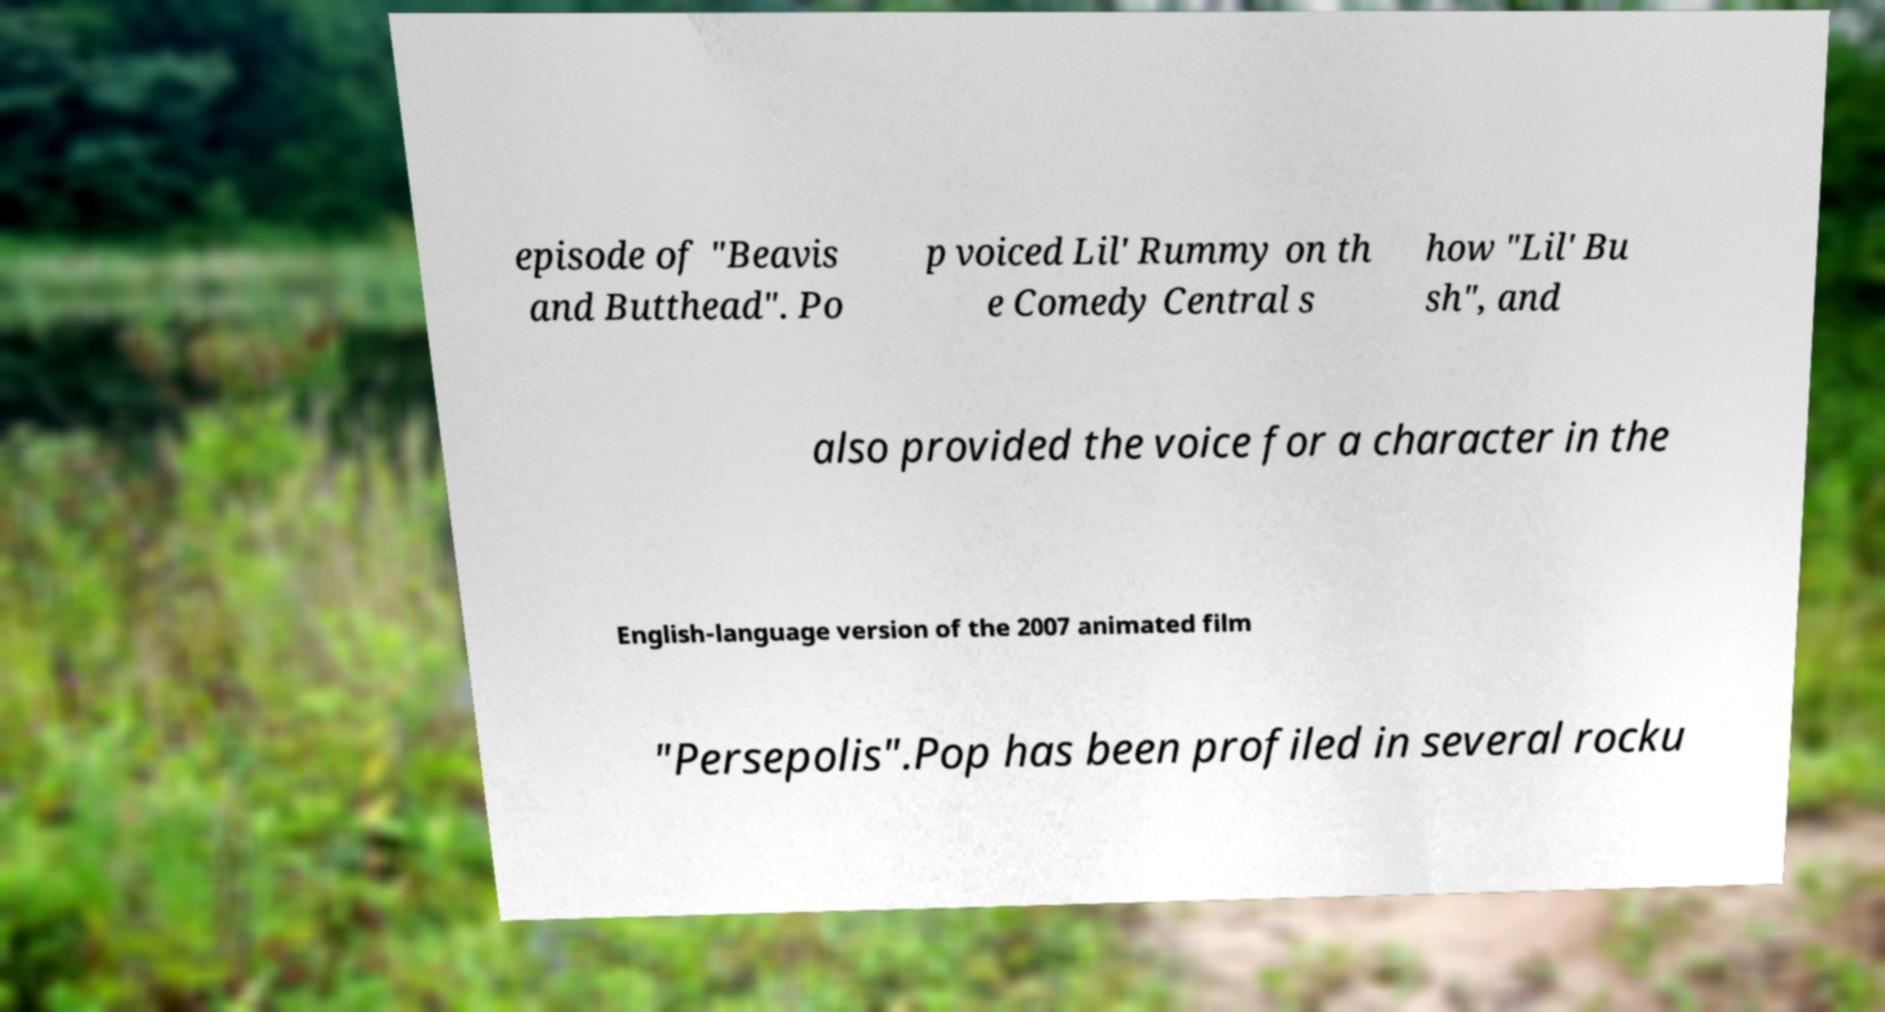What messages or text are displayed in this image? I need them in a readable, typed format. episode of "Beavis and Butthead". Po p voiced Lil' Rummy on th e Comedy Central s how "Lil' Bu sh", and also provided the voice for a character in the English-language version of the 2007 animated film "Persepolis".Pop has been profiled in several rocku 